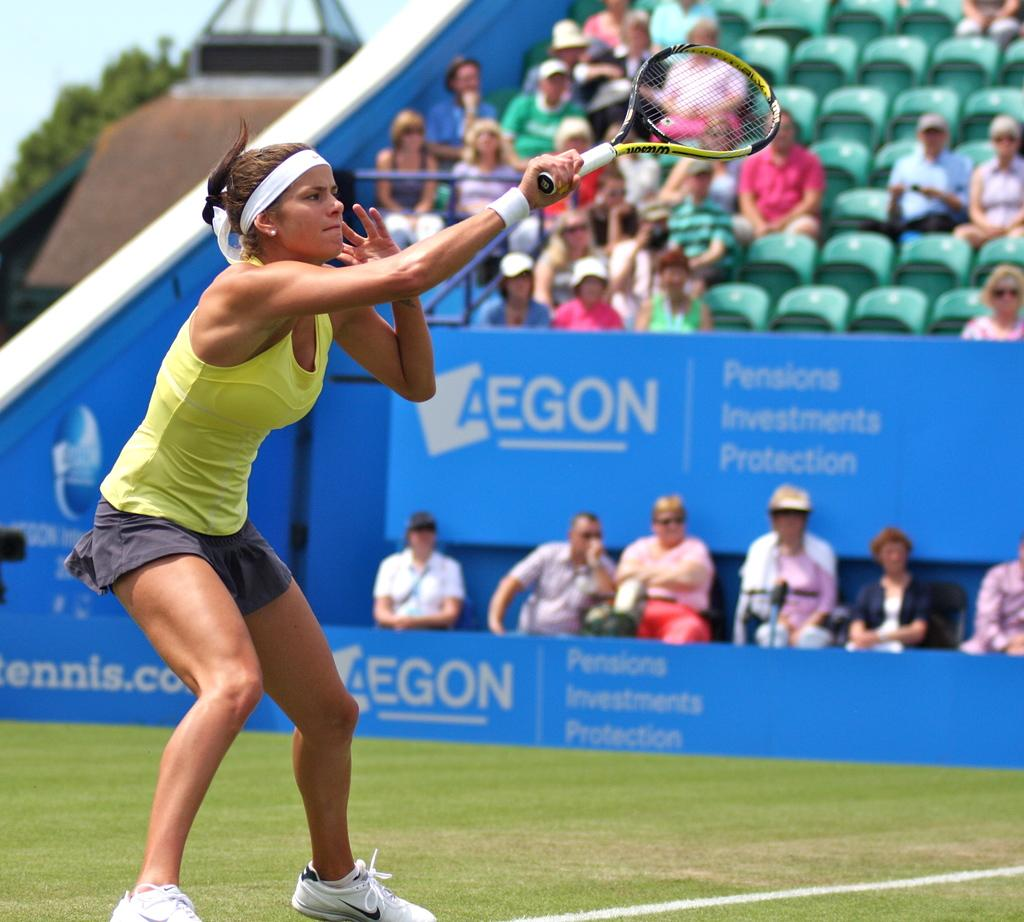Who is the main subject in the image? There is a woman in the image. What is the woman doing in the image? The woman is on the grass and holding a bat in her hand. Can you describe the background of the image? There are people in the background of the image, and they are sitting on chairs. What type of map is the woman using to tie a knot in the image? There is no map or knot-tying activity present in the image. 